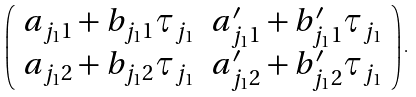Convert formula to latex. <formula><loc_0><loc_0><loc_500><loc_500>\left ( \begin{array} { c c } { a _ { j _ { 1 } 1 } } + { b _ { j _ { 1 } 1 } } \tau _ { j _ { 1 } } & { a ^ { \prime } _ { j _ { 1 } 1 } } + { b ^ { \prime } _ { j _ { 1 } 1 } } \tau _ { j _ { 1 } } \\ { a _ { j _ { 1 } 2 } } + { b _ { j _ { 1 } 2 } } \tau _ { j _ { 1 } } & { a ^ { \prime } _ { j _ { 1 } 2 } } + { b ^ { \prime } _ { j _ { 1 } 2 } } \tau _ { j _ { 1 } } \end{array} \right ) .</formula> 